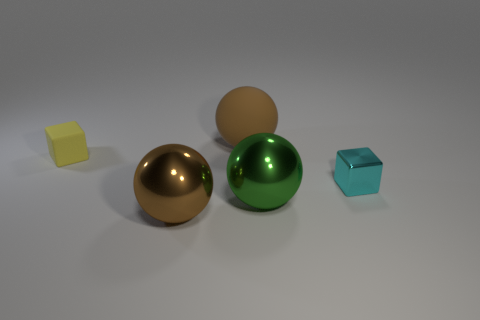Add 4 tiny cyan blocks. How many objects exist? 9 Subtract all brown matte balls. How many balls are left? 2 Subtract all brown cubes. How many brown spheres are left? 2 Subtract all balls. How many objects are left? 2 Subtract all matte balls. Subtract all big green metallic balls. How many objects are left? 3 Add 5 big brown balls. How many big brown balls are left? 7 Add 5 cyan objects. How many cyan objects exist? 6 Subtract 0 cyan cylinders. How many objects are left? 5 Subtract all brown spheres. Subtract all purple cylinders. How many spheres are left? 1 